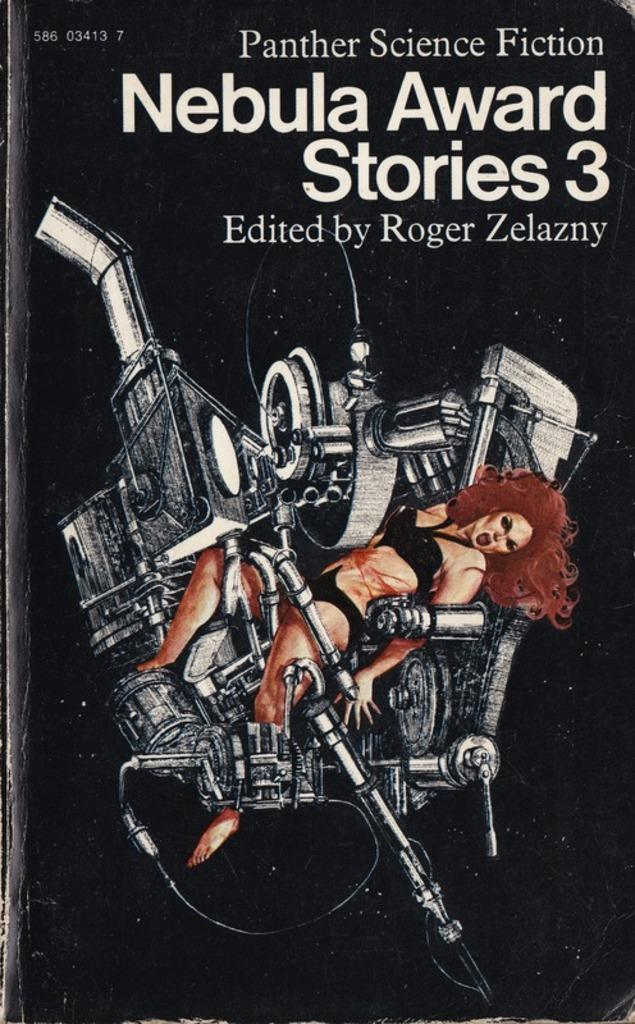<image>
Render a clear and concise summary of the photo. Roger Zelazny is the author of Panther Science Fiction Nebula Award Stories 3. 